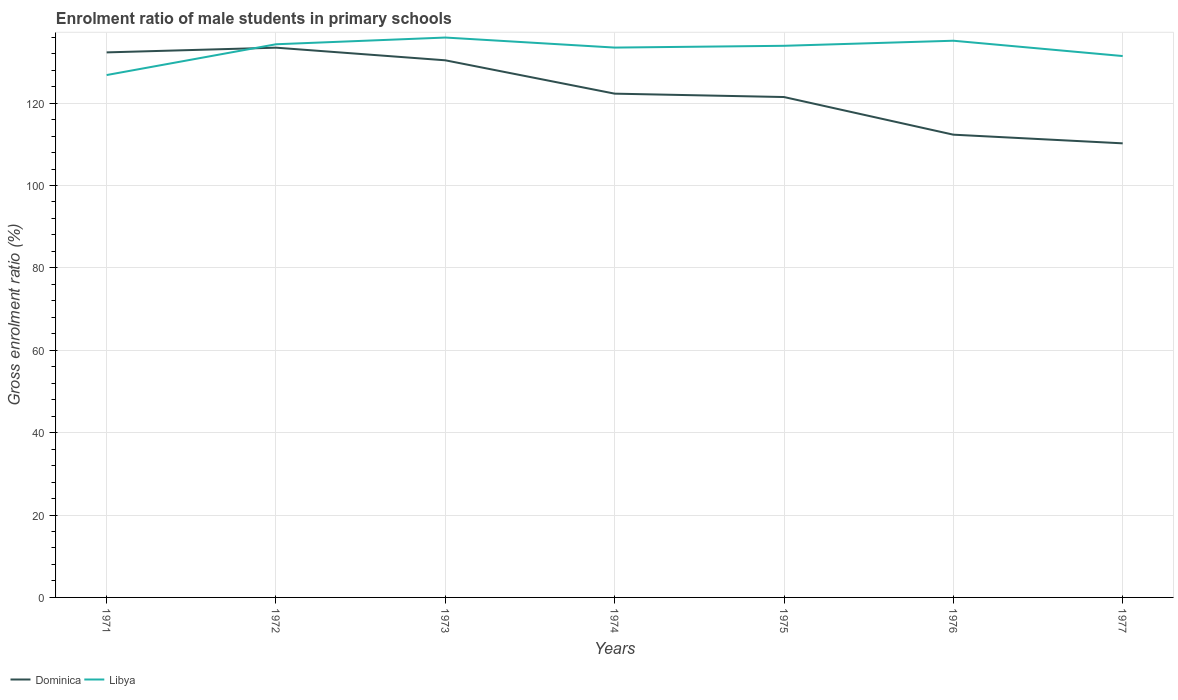How many different coloured lines are there?
Offer a terse response. 2. Does the line corresponding to Libya intersect with the line corresponding to Dominica?
Offer a terse response. Yes. Is the number of lines equal to the number of legend labels?
Provide a succinct answer. Yes. Across all years, what is the maximum enrolment ratio of male students in primary schools in Libya?
Your answer should be compact. 126.81. What is the total enrolment ratio of male students in primary schools in Libya in the graph?
Your answer should be compact. -0.43. What is the difference between the highest and the second highest enrolment ratio of male students in primary schools in Dominica?
Make the answer very short. 23.22. What is the difference between the highest and the lowest enrolment ratio of male students in primary schools in Dominica?
Provide a short and direct response. 3. What is the difference between two consecutive major ticks on the Y-axis?
Provide a short and direct response. 20. Are the values on the major ticks of Y-axis written in scientific E-notation?
Your response must be concise. No. Does the graph contain any zero values?
Make the answer very short. No. Does the graph contain grids?
Offer a very short reply. Yes. What is the title of the graph?
Your answer should be very brief. Enrolment ratio of male students in primary schools. Does "East Asia (developing only)" appear as one of the legend labels in the graph?
Offer a very short reply. No. What is the Gross enrolment ratio (%) in Dominica in 1971?
Give a very brief answer. 132.31. What is the Gross enrolment ratio (%) in Libya in 1971?
Offer a terse response. 126.81. What is the Gross enrolment ratio (%) in Dominica in 1972?
Give a very brief answer. 133.45. What is the Gross enrolment ratio (%) in Libya in 1972?
Offer a very short reply. 134.28. What is the Gross enrolment ratio (%) of Dominica in 1973?
Provide a succinct answer. 130.39. What is the Gross enrolment ratio (%) of Libya in 1973?
Ensure brevity in your answer.  135.91. What is the Gross enrolment ratio (%) of Dominica in 1974?
Ensure brevity in your answer.  122.29. What is the Gross enrolment ratio (%) of Libya in 1974?
Ensure brevity in your answer.  133.47. What is the Gross enrolment ratio (%) of Dominica in 1975?
Your response must be concise. 121.47. What is the Gross enrolment ratio (%) of Libya in 1975?
Provide a short and direct response. 133.91. What is the Gross enrolment ratio (%) in Dominica in 1976?
Ensure brevity in your answer.  112.33. What is the Gross enrolment ratio (%) in Libya in 1976?
Give a very brief answer. 135.14. What is the Gross enrolment ratio (%) of Dominica in 1977?
Provide a short and direct response. 110.23. What is the Gross enrolment ratio (%) of Libya in 1977?
Ensure brevity in your answer.  131.42. Across all years, what is the maximum Gross enrolment ratio (%) of Dominica?
Give a very brief answer. 133.45. Across all years, what is the maximum Gross enrolment ratio (%) of Libya?
Provide a short and direct response. 135.91. Across all years, what is the minimum Gross enrolment ratio (%) of Dominica?
Make the answer very short. 110.23. Across all years, what is the minimum Gross enrolment ratio (%) in Libya?
Give a very brief answer. 126.81. What is the total Gross enrolment ratio (%) of Dominica in the graph?
Your answer should be very brief. 862.47. What is the total Gross enrolment ratio (%) of Libya in the graph?
Keep it short and to the point. 930.94. What is the difference between the Gross enrolment ratio (%) of Dominica in 1971 and that in 1972?
Your response must be concise. -1.15. What is the difference between the Gross enrolment ratio (%) in Libya in 1971 and that in 1972?
Ensure brevity in your answer.  -7.47. What is the difference between the Gross enrolment ratio (%) of Dominica in 1971 and that in 1973?
Provide a succinct answer. 1.92. What is the difference between the Gross enrolment ratio (%) in Libya in 1971 and that in 1973?
Ensure brevity in your answer.  -9.1. What is the difference between the Gross enrolment ratio (%) of Dominica in 1971 and that in 1974?
Keep it short and to the point. 10.02. What is the difference between the Gross enrolment ratio (%) of Libya in 1971 and that in 1974?
Your response must be concise. -6.67. What is the difference between the Gross enrolment ratio (%) in Dominica in 1971 and that in 1975?
Make the answer very short. 10.84. What is the difference between the Gross enrolment ratio (%) of Libya in 1971 and that in 1975?
Your answer should be compact. -7.1. What is the difference between the Gross enrolment ratio (%) of Dominica in 1971 and that in 1976?
Make the answer very short. 19.97. What is the difference between the Gross enrolment ratio (%) in Libya in 1971 and that in 1976?
Offer a very short reply. -8.33. What is the difference between the Gross enrolment ratio (%) in Dominica in 1971 and that in 1977?
Your response must be concise. 22.08. What is the difference between the Gross enrolment ratio (%) in Libya in 1971 and that in 1977?
Your answer should be very brief. -4.61. What is the difference between the Gross enrolment ratio (%) in Dominica in 1972 and that in 1973?
Offer a terse response. 3.07. What is the difference between the Gross enrolment ratio (%) of Libya in 1972 and that in 1973?
Ensure brevity in your answer.  -1.63. What is the difference between the Gross enrolment ratio (%) of Dominica in 1972 and that in 1974?
Give a very brief answer. 11.16. What is the difference between the Gross enrolment ratio (%) of Libya in 1972 and that in 1974?
Your response must be concise. 0.81. What is the difference between the Gross enrolment ratio (%) of Dominica in 1972 and that in 1975?
Ensure brevity in your answer.  11.98. What is the difference between the Gross enrolment ratio (%) in Libya in 1972 and that in 1975?
Your response must be concise. 0.37. What is the difference between the Gross enrolment ratio (%) in Dominica in 1972 and that in 1976?
Offer a very short reply. 21.12. What is the difference between the Gross enrolment ratio (%) of Libya in 1972 and that in 1976?
Provide a short and direct response. -0.86. What is the difference between the Gross enrolment ratio (%) in Dominica in 1972 and that in 1977?
Your answer should be very brief. 23.22. What is the difference between the Gross enrolment ratio (%) of Libya in 1972 and that in 1977?
Your answer should be compact. 2.86. What is the difference between the Gross enrolment ratio (%) of Dominica in 1973 and that in 1974?
Provide a succinct answer. 8.1. What is the difference between the Gross enrolment ratio (%) in Libya in 1973 and that in 1974?
Your answer should be compact. 2.44. What is the difference between the Gross enrolment ratio (%) of Dominica in 1973 and that in 1975?
Keep it short and to the point. 8.92. What is the difference between the Gross enrolment ratio (%) of Libya in 1973 and that in 1975?
Ensure brevity in your answer.  2.01. What is the difference between the Gross enrolment ratio (%) in Dominica in 1973 and that in 1976?
Give a very brief answer. 18.05. What is the difference between the Gross enrolment ratio (%) of Libya in 1973 and that in 1976?
Provide a succinct answer. 0.77. What is the difference between the Gross enrolment ratio (%) in Dominica in 1973 and that in 1977?
Your response must be concise. 20.16. What is the difference between the Gross enrolment ratio (%) in Libya in 1973 and that in 1977?
Give a very brief answer. 4.49. What is the difference between the Gross enrolment ratio (%) in Dominica in 1974 and that in 1975?
Offer a terse response. 0.82. What is the difference between the Gross enrolment ratio (%) of Libya in 1974 and that in 1975?
Provide a short and direct response. -0.43. What is the difference between the Gross enrolment ratio (%) of Dominica in 1974 and that in 1976?
Provide a short and direct response. 9.96. What is the difference between the Gross enrolment ratio (%) in Libya in 1974 and that in 1976?
Provide a short and direct response. -1.66. What is the difference between the Gross enrolment ratio (%) of Dominica in 1974 and that in 1977?
Offer a terse response. 12.06. What is the difference between the Gross enrolment ratio (%) of Libya in 1974 and that in 1977?
Your answer should be compact. 2.06. What is the difference between the Gross enrolment ratio (%) in Dominica in 1975 and that in 1976?
Provide a short and direct response. 9.14. What is the difference between the Gross enrolment ratio (%) of Libya in 1975 and that in 1976?
Provide a short and direct response. -1.23. What is the difference between the Gross enrolment ratio (%) in Dominica in 1975 and that in 1977?
Offer a terse response. 11.24. What is the difference between the Gross enrolment ratio (%) in Libya in 1975 and that in 1977?
Make the answer very short. 2.49. What is the difference between the Gross enrolment ratio (%) of Dominica in 1976 and that in 1977?
Your response must be concise. 2.1. What is the difference between the Gross enrolment ratio (%) of Libya in 1976 and that in 1977?
Your response must be concise. 3.72. What is the difference between the Gross enrolment ratio (%) in Dominica in 1971 and the Gross enrolment ratio (%) in Libya in 1972?
Your answer should be compact. -1.97. What is the difference between the Gross enrolment ratio (%) in Dominica in 1971 and the Gross enrolment ratio (%) in Libya in 1973?
Your answer should be compact. -3.6. What is the difference between the Gross enrolment ratio (%) of Dominica in 1971 and the Gross enrolment ratio (%) of Libya in 1974?
Keep it short and to the point. -1.17. What is the difference between the Gross enrolment ratio (%) of Dominica in 1971 and the Gross enrolment ratio (%) of Libya in 1975?
Provide a short and direct response. -1.6. What is the difference between the Gross enrolment ratio (%) of Dominica in 1971 and the Gross enrolment ratio (%) of Libya in 1976?
Your answer should be very brief. -2.83. What is the difference between the Gross enrolment ratio (%) of Dominica in 1971 and the Gross enrolment ratio (%) of Libya in 1977?
Provide a short and direct response. 0.89. What is the difference between the Gross enrolment ratio (%) in Dominica in 1972 and the Gross enrolment ratio (%) in Libya in 1973?
Provide a short and direct response. -2.46. What is the difference between the Gross enrolment ratio (%) in Dominica in 1972 and the Gross enrolment ratio (%) in Libya in 1974?
Offer a very short reply. -0.02. What is the difference between the Gross enrolment ratio (%) in Dominica in 1972 and the Gross enrolment ratio (%) in Libya in 1975?
Offer a terse response. -0.45. What is the difference between the Gross enrolment ratio (%) of Dominica in 1972 and the Gross enrolment ratio (%) of Libya in 1976?
Your answer should be very brief. -1.68. What is the difference between the Gross enrolment ratio (%) of Dominica in 1972 and the Gross enrolment ratio (%) of Libya in 1977?
Keep it short and to the point. 2.03. What is the difference between the Gross enrolment ratio (%) in Dominica in 1973 and the Gross enrolment ratio (%) in Libya in 1974?
Offer a very short reply. -3.09. What is the difference between the Gross enrolment ratio (%) in Dominica in 1973 and the Gross enrolment ratio (%) in Libya in 1975?
Provide a short and direct response. -3.52. What is the difference between the Gross enrolment ratio (%) in Dominica in 1973 and the Gross enrolment ratio (%) in Libya in 1976?
Provide a succinct answer. -4.75. What is the difference between the Gross enrolment ratio (%) in Dominica in 1973 and the Gross enrolment ratio (%) in Libya in 1977?
Provide a succinct answer. -1.03. What is the difference between the Gross enrolment ratio (%) of Dominica in 1974 and the Gross enrolment ratio (%) of Libya in 1975?
Ensure brevity in your answer.  -11.62. What is the difference between the Gross enrolment ratio (%) in Dominica in 1974 and the Gross enrolment ratio (%) in Libya in 1976?
Offer a very short reply. -12.85. What is the difference between the Gross enrolment ratio (%) in Dominica in 1974 and the Gross enrolment ratio (%) in Libya in 1977?
Provide a short and direct response. -9.13. What is the difference between the Gross enrolment ratio (%) of Dominica in 1975 and the Gross enrolment ratio (%) of Libya in 1976?
Your answer should be very brief. -13.67. What is the difference between the Gross enrolment ratio (%) of Dominica in 1975 and the Gross enrolment ratio (%) of Libya in 1977?
Your answer should be very brief. -9.95. What is the difference between the Gross enrolment ratio (%) in Dominica in 1976 and the Gross enrolment ratio (%) in Libya in 1977?
Offer a terse response. -19.09. What is the average Gross enrolment ratio (%) in Dominica per year?
Your response must be concise. 123.21. What is the average Gross enrolment ratio (%) of Libya per year?
Make the answer very short. 132.99. In the year 1971, what is the difference between the Gross enrolment ratio (%) in Dominica and Gross enrolment ratio (%) in Libya?
Provide a short and direct response. 5.5. In the year 1972, what is the difference between the Gross enrolment ratio (%) in Dominica and Gross enrolment ratio (%) in Libya?
Ensure brevity in your answer.  -0.83. In the year 1973, what is the difference between the Gross enrolment ratio (%) of Dominica and Gross enrolment ratio (%) of Libya?
Offer a terse response. -5.53. In the year 1974, what is the difference between the Gross enrolment ratio (%) in Dominica and Gross enrolment ratio (%) in Libya?
Your answer should be very brief. -11.18. In the year 1975, what is the difference between the Gross enrolment ratio (%) in Dominica and Gross enrolment ratio (%) in Libya?
Ensure brevity in your answer.  -12.44. In the year 1976, what is the difference between the Gross enrolment ratio (%) of Dominica and Gross enrolment ratio (%) of Libya?
Your response must be concise. -22.81. In the year 1977, what is the difference between the Gross enrolment ratio (%) of Dominica and Gross enrolment ratio (%) of Libya?
Provide a succinct answer. -21.19. What is the ratio of the Gross enrolment ratio (%) in Dominica in 1971 to that in 1972?
Ensure brevity in your answer.  0.99. What is the ratio of the Gross enrolment ratio (%) of Libya in 1971 to that in 1972?
Ensure brevity in your answer.  0.94. What is the ratio of the Gross enrolment ratio (%) in Dominica in 1971 to that in 1973?
Provide a short and direct response. 1.01. What is the ratio of the Gross enrolment ratio (%) of Libya in 1971 to that in 1973?
Your response must be concise. 0.93. What is the ratio of the Gross enrolment ratio (%) of Dominica in 1971 to that in 1974?
Ensure brevity in your answer.  1.08. What is the ratio of the Gross enrolment ratio (%) of Libya in 1971 to that in 1974?
Provide a short and direct response. 0.95. What is the ratio of the Gross enrolment ratio (%) of Dominica in 1971 to that in 1975?
Provide a succinct answer. 1.09. What is the ratio of the Gross enrolment ratio (%) in Libya in 1971 to that in 1975?
Offer a very short reply. 0.95. What is the ratio of the Gross enrolment ratio (%) of Dominica in 1971 to that in 1976?
Give a very brief answer. 1.18. What is the ratio of the Gross enrolment ratio (%) in Libya in 1971 to that in 1976?
Keep it short and to the point. 0.94. What is the ratio of the Gross enrolment ratio (%) in Dominica in 1971 to that in 1977?
Provide a short and direct response. 1.2. What is the ratio of the Gross enrolment ratio (%) of Libya in 1971 to that in 1977?
Your answer should be very brief. 0.96. What is the ratio of the Gross enrolment ratio (%) in Dominica in 1972 to that in 1973?
Provide a short and direct response. 1.02. What is the ratio of the Gross enrolment ratio (%) in Libya in 1972 to that in 1973?
Your answer should be very brief. 0.99. What is the ratio of the Gross enrolment ratio (%) in Dominica in 1972 to that in 1974?
Ensure brevity in your answer.  1.09. What is the ratio of the Gross enrolment ratio (%) of Libya in 1972 to that in 1974?
Offer a very short reply. 1.01. What is the ratio of the Gross enrolment ratio (%) in Dominica in 1972 to that in 1975?
Give a very brief answer. 1.1. What is the ratio of the Gross enrolment ratio (%) of Dominica in 1972 to that in 1976?
Keep it short and to the point. 1.19. What is the ratio of the Gross enrolment ratio (%) of Dominica in 1972 to that in 1977?
Provide a short and direct response. 1.21. What is the ratio of the Gross enrolment ratio (%) of Libya in 1972 to that in 1977?
Provide a short and direct response. 1.02. What is the ratio of the Gross enrolment ratio (%) in Dominica in 1973 to that in 1974?
Offer a very short reply. 1.07. What is the ratio of the Gross enrolment ratio (%) of Libya in 1973 to that in 1974?
Ensure brevity in your answer.  1.02. What is the ratio of the Gross enrolment ratio (%) in Dominica in 1973 to that in 1975?
Keep it short and to the point. 1.07. What is the ratio of the Gross enrolment ratio (%) in Dominica in 1973 to that in 1976?
Make the answer very short. 1.16. What is the ratio of the Gross enrolment ratio (%) in Dominica in 1973 to that in 1977?
Offer a terse response. 1.18. What is the ratio of the Gross enrolment ratio (%) of Libya in 1973 to that in 1977?
Ensure brevity in your answer.  1.03. What is the ratio of the Gross enrolment ratio (%) in Dominica in 1974 to that in 1975?
Ensure brevity in your answer.  1.01. What is the ratio of the Gross enrolment ratio (%) of Libya in 1974 to that in 1975?
Give a very brief answer. 1. What is the ratio of the Gross enrolment ratio (%) of Dominica in 1974 to that in 1976?
Offer a terse response. 1.09. What is the ratio of the Gross enrolment ratio (%) in Dominica in 1974 to that in 1977?
Provide a short and direct response. 1.11. What is the ratio of the Gross enrolment ratio (%) in Libya in 1974 to that in 1977?
Your response must be concise. 1.02. What is the ratio of the Gross enrolment ratio (%) in Dominica in 1975 to that in 1976?
Keep it short and to the point. 1.08. What is the ratio of the Gross enrolment ratio (%) in Libya in 1975 to that in 1976?
Ensure brevity in your answer.  0.99. What is the ratio of the Gross enrolment ratio (%) of Dominica in 1975 to that in 1977?
Your answer should be compact. 1.1. What is the ratio of the Gross enrolment ratio (%) in Libya in 1975 to that in 1977?
Provide a short and direct response. 1.02. What is the ratio of the Gross enrolment ratio (%) of Dominica in 1976 to that in 1977?
Keep it short and to the point. 1.02. What is the ratio of the Gross enrolment ratio (%) of Libya in 1976 to that in 1977?
Offer a very short reply. 1.03. What is the difference between the highest and the second highest Gross enrolment ratio (%) in Dominica?
Ensure brevity in your answer.  1.15. What is the difference between the highest and the second highest Gross enrolment ratio (%) in Libya?
Offer a terse response. 0.77. What is the difference between the highest and the lowest Gross enrolment ratio (%) of Dominica?
Keep it short and to the point. 23.22. What is the difference between the highest and the lowest Gross enrolment ratio (%) in Libya?
Provide a short and direct response. 9.1. 